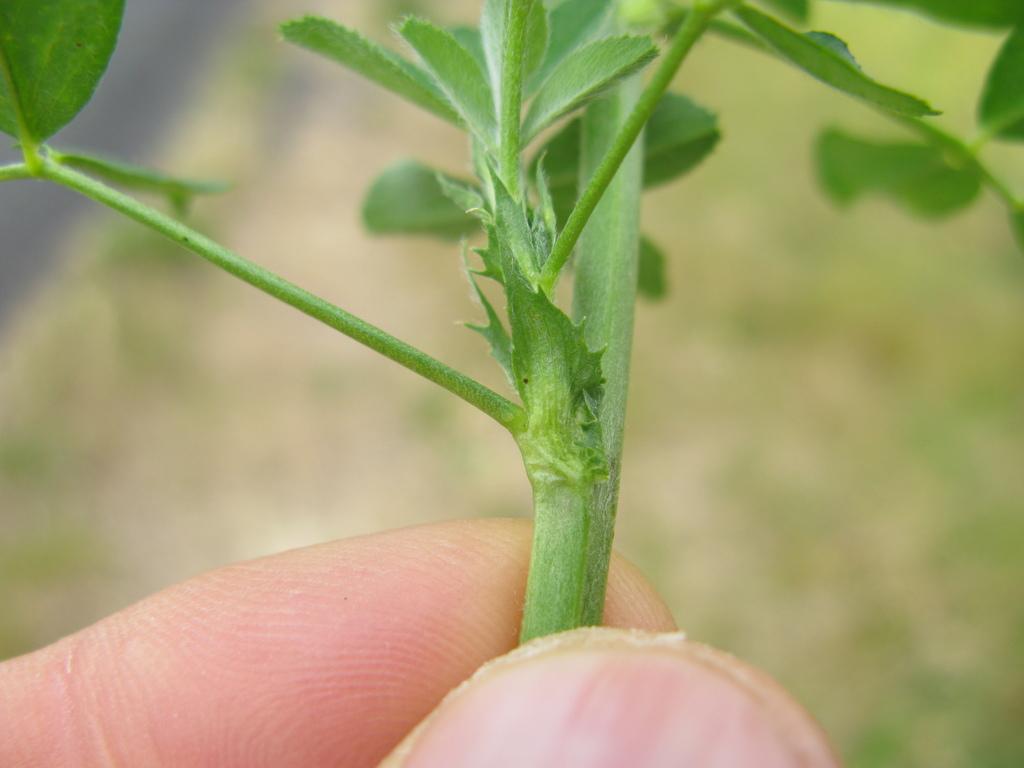Can you describe this image briefly? In this picture I can see a person hands and holding a stem of a plant. 